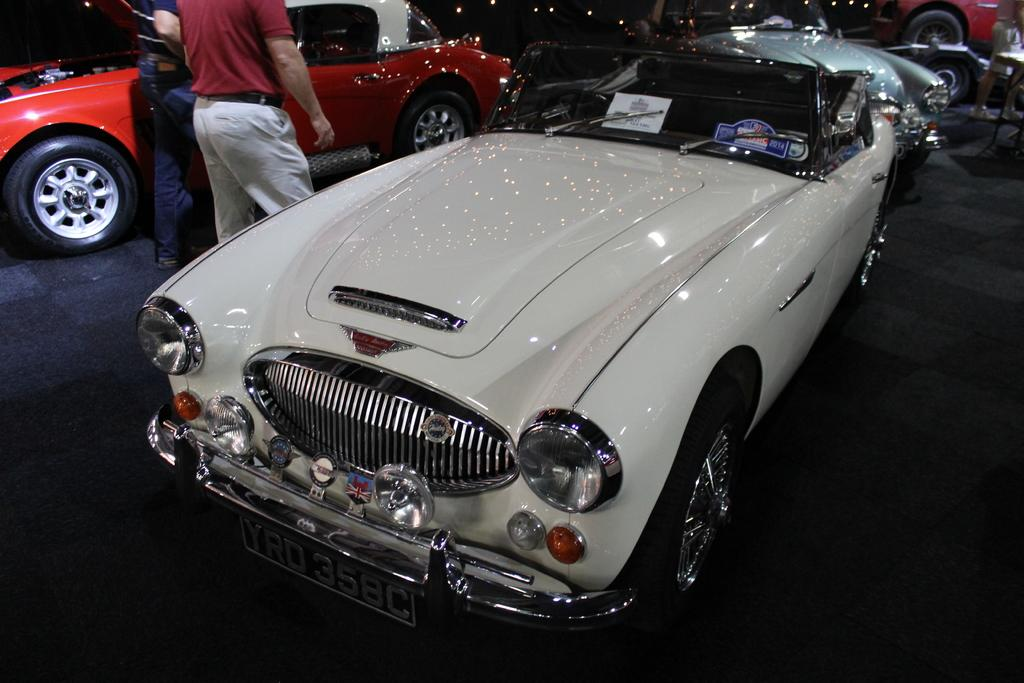What type of vehicles can be seen in the image? There are cars in the image. What else is present in the image besides cars? There are people standing in the image, as well as a board and papers. What is written on the board? Something is written on the board, but the specific content is not mentioned in the facts. What might the papers be used for? The papers could be used for various purposes, such as notes or documents, but their specific use is not mentioned in the facts. What type of book is being read by the people in the image? There is no book present in the image; it only mentions people standing and a board with writing on it. 